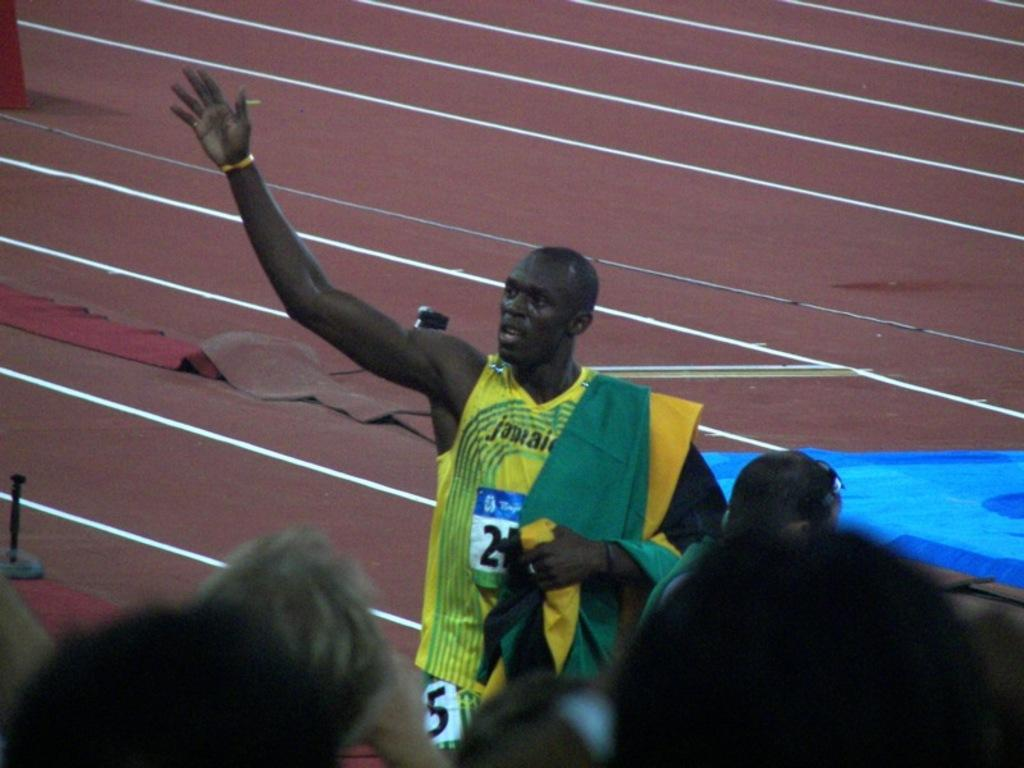Who is present at the bottom of the image? There are people at the bottom of the image. Can you describe the appearance of a specific person in the image? There is a man in a yellow dress in the image, and he is stunning. What is the color and pattern of the floor in the background of the image? The floor in the background of the image is brown with white lines. What riddle does the girl in the image pose to the viewers? There is no girl present in the image, so no riddle can be posed by her. 